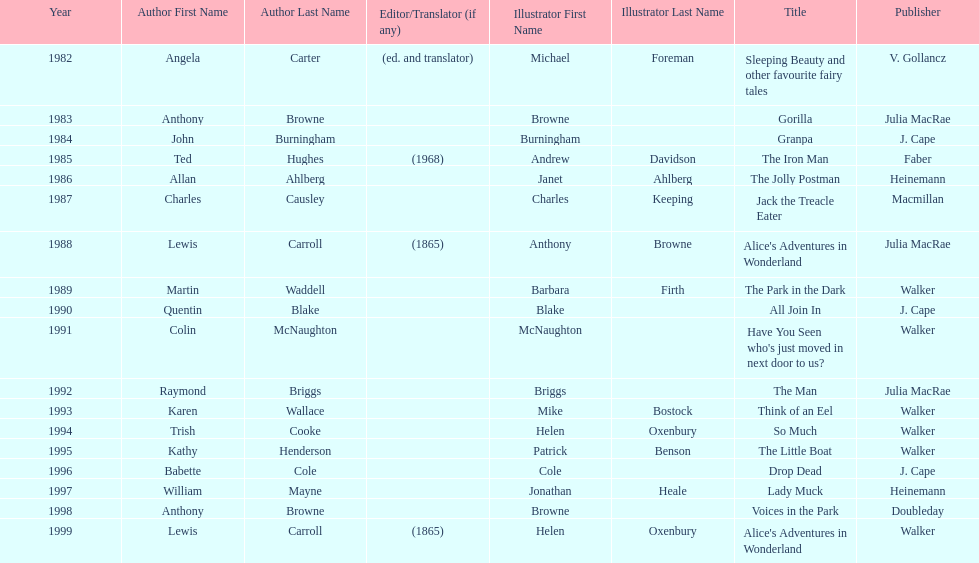What's the difference in years between angela carter's title and anthony browne's? 1. 